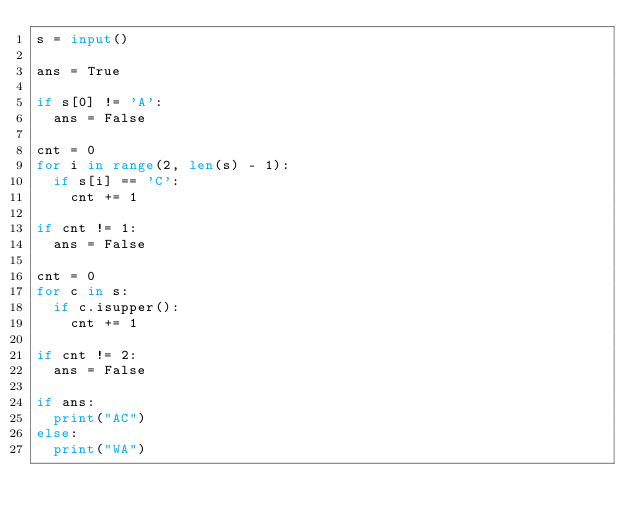<code> <loc_0><loc_0><loc_500><loc_500><_Python_>s = input()

ans = True

if s[0] != 'A':
  ans = False
  
cnt = 0
for i in range(2, len(s) - 1):
  if s[i] == 'C':
    cnt += 1
    
if cnt != 1:
  ans = False
  
cnt = 0
for c in s:
  if c.isupper():
    cnt += 1
    
if cnt != 2:
  ans = False
  
if ans:
  print("AC")
else:
  print("WA")</code> 